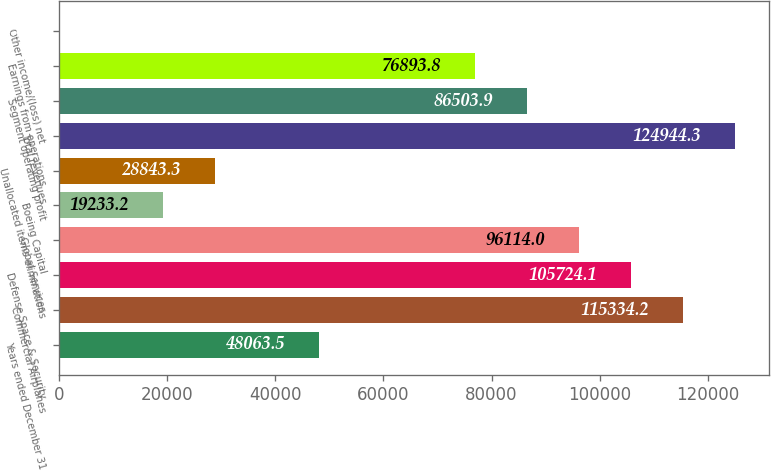Convert chart. <chart><loc_0><loc_0><loc_500><loc_500><bar_chart><fcel>Years ended December 31<fcel>Commercial Airplanes<fcel>Defense Space & Security<fcel>Global Services<fcel>Boeing Capital<fcel>Unallocated items eliminations<fcel>Total revenues<fcel>Segment operating profit<fcel>Earnings from operations<fcel>Other income/(loss) net<nl><fcel>48063.5<fcel>115334<fcel>105724<fcel>96114<fcel>19233.2<fcel>28843.3<fcel>124944<fcel>86503.9<fcel>76893.8<fcel>13<nl></chart> 